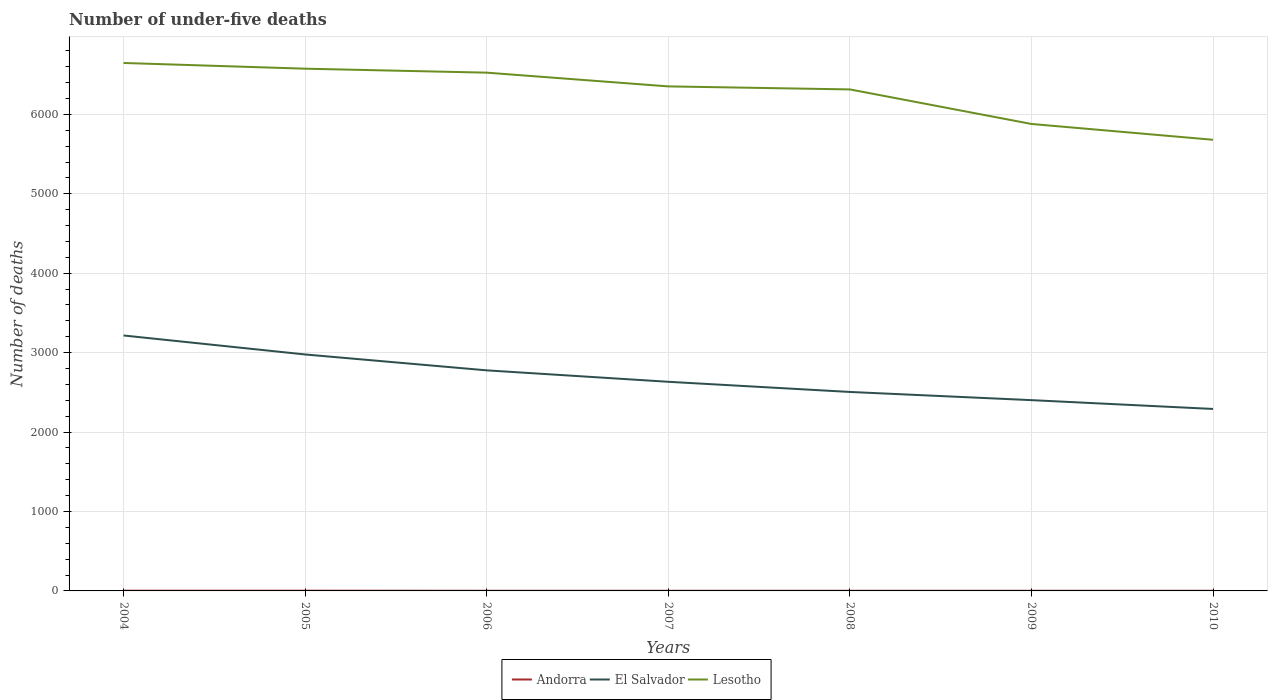How many different coloured lines are there?
Offer a very short reply. 3. Is the number of lines equal to the number of legend labels?
Keep it short and to the point. Yes. Across all years, what is the maximum number of under-five deaths in Lesotho?
Provide a short and direct response. 5680. In which year was the number of under-five deaths in El Salvador maximum?
Offer a very short reply. 2010. What is the difference between the highest and the second highest number of under-five deaths in Lesotho?
Ensure brevity in your answer.  967. Where does the legend appear in the graph?
Your answer should be compact. Bottom center. How many legend labels are there?
Keep it short and to the point. 3. How are the legend labels stacked?
Your answer should be compact. Horizontal. What is the title of the graph?
Offer a terse response. Number of under-five deaths. What is the label or title of the X-axis?
Provide a short and direct response. Years. What is the label or title of the Y-axis?
Offer a very short reply. Number of deaths. What is the Number of deaths in El Salvador in 2004?
Keep it short and to the point. 3216. What is the Number of deaths in Lesotho in 2004?
Ensure brevity in your answer.  6647. What is the Number of deaths in El Salvador in 2005?
Offer a terse response. 2977. What is the Number of deaths of Lesotho in 2005?
Your answer should be very brief. 6575. What is the Number of deaths in El Salvador in 2006?
Keep it short and to the point. 2777. What is the Number of deaths of Lesotho in 2006?
Provide a succinct answer. 6525. What is the Number of deaths in Andorra in 2007?
Your answer should be compact. 2. What is the Number of deaths in El Salvador in 2007?
Keep it short and to the point. 2633. What is the Number of deaths in Lesotho in 2007?
Give a very brief answer. 6352. What is the Number of deaths of Andorra in 2008?
Make the answer very short. 2. What is the Number of deaths of El Salvador in 2008?
Make the answer very short. 2505. What is the Number of deaths of Lesotho in 2008?
Provide a succinct answer. 6314. What is the Number of deaths in El Salvador in 2009?
Your answer should be compact. 2402. What is the Number of deaths of Lesotho in 2009?
Keep it short and to the point. 5879. What is the Number of deaths of Andorra in 2010?
Your answer should be very brief. 2. What is the Number of deaths of El Salvador in 2010?
Provide a short and direct response. 2291. What is the Number of deaths of Lesotho in 2010?
Your answer should be very brief. 5680. Across all years, what is the maximum Number of deaths in El Salvador?
Offer a terse response. 3216. Across all years, what is the maximum Number of deaths of Lesotho?
Ensure brevity in your answer.  6647. Across all years, what is the minimum Number of deaths of El Salvador?
Make the answer very short. 2291. Across all years, what is the minimum Number of deaths in Lesotho?
Offer a terse response. 5680. What is the total Number of deaths of Andorra in the graph?
Keep it short and to the point. 16. What is the total Number of deaths of El Salvador in the graph?
Your response must be concise. 1.88e+04. What is the total Number of deaths of Lesotho in the graph?
Ensure brevity in your answer.  4.40e+04. What is the difference between the Number of deaths in Andorra in 2004 and that in 2005?
Keep it short and to the point. 0. What is the difference between the Number of deaths in El Salvador in 2004 and that in 2005?
Your response must be concise. 239. What is the difference between the Number of deaths in Andorra in 2004 and that in 2006?
Make the answer very short. 1. What is the difference between the Number of deaths of El Salvador in 2004 and that in 2006?
Provide a succinct answer. 439. What is the difference between the Number of deaths in Lesotho in 2004 and that in 2006?
Make the answer very short. 122. What is the difference between the Number of deaths of Andorra in 2004 and that in 2007?
Give a very brief answer. 1. What is the difference between the Number of deaths of El Salvador in 2004 and that in 2007?
Provide a succinct answer. 583. What is the difference between the Number of deaths of Lesotho in 2004 and that in 2007?
Provide a succinct answer. 295. What is the difference between the Number of deaths in El Salvador in 2004 and that in 2008?
Ensure brevity in your answer.  711. What is the difference between the Number of deaths of Lesotho in 2004 and that in 2008?
Provide a succinct answer. 333. What is the difference between the Number of deaths of Andorra in 2004 and that in 2009?
Keep it short and to the point. 1. What is the difference between the Number of deaths of El Salvador in 2004 and that in 2009?
Provide a short and direct response. 814. What is the difference between the Number of deaths of Lesotho in 2004 and that in 2009?
Your answer should be compact. 768. What is the difference between the Number of deaths of Andorra in 2004 and that in 2010?
Ensure brevity in your answer.  1. What is the difference between the Number of deaths in El Salvador in 2004 and that in 2010?
Your answer should be very brief. 925. What is the difference between the Number of deaths in Lesotho in 2004 and that in 2010?
Provide a short and direct response. 967. What is the difference between the Number of deaths in El Salvador in 2005 and that in 2007?
Ensure brevity in your answer.  344. What is the difference between the Number of deaths of Lesotho in 2005 and that in 2007?
Offer a very short reply. 223. What is the difference between the Number of deaths of Andorra in 2005 and that in 2008?
Offer a very short reply. 1. What is the difference between the Number of deaths in El Salvador in 2005 and that in 2008?
Make the answer very short. 472. What is the difference between the Number of deaths in Lesotho in 2005 and that in 2008?
Your answer should be compact. 261. What is the difference between the Number of deaths in El Salvador in 2005 and that in 2009?
Provide a short and direct response. 575. What is the difference between the Number of deaths of Lesotho in 2005 and that in 2009?
Your answer should be compact. 696. What is the difference between the Number of deaths in El Salvador in 2005 and that in 2010?
Your answer should be compact. 686. What is the difference between the Number of deaths of Lesotho in 2005 and that in 2010?
Keep it short and to the point. 895. What is the difference between the Number of deaths of Andorra in 2006 and that in 2007?
Your answer should be compact. 0. What is the difference between the Number of deaths in El Salvador in 2006 and that in 2007?
Your answer should be very brief. 144. What is the difference between the Number of deaths in Lesotho in 2006 and that in 2007?
Offer a very short reply. 173. What is the difference between the Number of deaths in El Salvador in 2006 and that in 2008?
Offer a very short reply. 272. What is the difference between the Number of deaths of Lesotho in 2006 and that in 2008?
Offer a very short reply. 211. What is the difference between the Number of deaths of El Salvador in 2006 and that in 2009?
Offer a terse response. 375. What is the difference between the Number of deaths in Lesotho in 2006 and that in 2009?
Keep it short and to the point. 646. What is the difference between the Number of deaths in Andorra in 2006 and that in 2010?
Provide a succinct answer. 0. What is the difference between the Number of deaths of El Salvador in 2006 and that in 2010?
Give a very brief answer. 486. What is the difference between the Number of deaths in Lesotho in 2006 and that in 2010?
Offer a very short reply. 845. What is the difference between the Number of deaths of Andorra in 2007 and that in 2008?
Give a very brief answer. 0. What is the difference between the Number of deaths of El Salvador in 2007 and that in 2008?
Give a very brief answer. 128. What is the difference between the Number of deaths in Lesotho in 2007 and that in 2008?
Ensure brevity in your answer.  38. What is the difference between the Number of deaths in El Salvador in 2007 and that in 2009?
Offer a very short reply. 231. What is the difference between the Number of deaths of Lesotho in 2007 and that in 2009?
Your answer should be compact. 473. What is the difference between the Number of deaths of Andorra in 2007 and that in 2010?
Provide a succinct answer. 0. What is the difference between the Number of deaths of El Salvador in 2007 and that in 2010?
Make the answer very short. 342. What is the difference between the Number of deaths of Lesotho in 2007 and that in 2010?
Provide a succinct answer. 672. What is the difference between the Number of deaths of El Salvador in 2008 and that in 2009?
Provide a short and direct response. 103. What is the difference between the Number of deaths of Lesotho in 2008 and that in 2009?
Give a very brief answer. 435. What is the difference between the Number of deaths in Andorra in 2008 and that in 2010?
Provide a succinct answer. 0. What is the difference between the Number of deaths in El Salvador in 2008 and that in 2010?
Your answer should be very brief. 214. What is the difference between the Number of deaths of Lesotho in 2008 and that in 2010?
Give a very brief answer. 634. What is the difference between the Number of deaths of El Salvador in 2009 and that in 2010?
Your answer should be compact. 111. What is the difference between the Number of deaths of Lesotho in 2009 and that in 2010?
Keep it short and to the point. 199. What is the difference between the Number of deaths in Andorra in 2004 and the Number of deaths in El Salvador in 2005?
Your response must be concise. -2974. What is the difference between the Number of deaths in Andorra in 2004 and the Number of deaths in Lesotho in 2005?
Provide a short and direct response. -6572. What is the difference between the Number of deaths in El Salvador in 2004 and the Number of deaths in Lesotho in 2005?
Keep it short and to the point. -3359. What is the difference between the Number of deaths of Andorra in 2004 and the Number of deaths of El Salvador in 2006?
Provide a succinct answer. -2774. What is the difference between the Number of deaths of Andorra in 2004 and the Number of deaths of Lesotho in 2006?
Offer a terse response. -6522. What is the difference between the Number of deaths in El Salvador in 2004 and the Number of deaths in Lesotho in 2006?
Your answer should be very brief. -3309. What is the difference between the Number of deaths in Andorra in 2004 and the Number of deaths in El Salvador in 2007?
Your answer should be compact. -2630. What is the difference between the Number of deaths of Andorra in 2004 and the Number of deaths of Lesotho in 2007?
Offer a very short reply. -6349. What is the difference between the Number of deaths of El Salvador in 2004 and the Number of deaths of Lesotho in 2007?
Your answer should be compact. -3136. What is the difference between the Number of deaths of Andorra in 2004 and the Number of deaths of El Salvador in 2008?
Provide a short and direct response. -2502. What is the difference between the Number of deaths in Andorra in 2004 and the Number of deaths in Lesotho in 2008?
Offer a terse response. -6311. What is the difference between the Number of deaths in El Salvador in 2004 and the Number of deaths in Lesotho in 2008?
Your response must be concise. -3098. What is the difference between the Number of deaths in Andorra in 2004 and the Number of deaths in El Salvador in 2009?
Give a very brief answer. -2399. What is the difference between the Number of deaths of Andorra in 2004 and the Number of deaths of Lesotho in 2009?
Your response must be concise. -5876. What is the difference between the Number of deaths in El Salvador in 2004 and the Number of deaths in Lesotho in 2009?
Give a very brief answer. -2663. What is the difference between the Number of deaths of Andorra in 2004 and the Number of deaths of El Salvador in 2010?
Your answer should be compact. -2288. What is the difference between the Number of deaths in Andorra in 2004 and the Number of deaths in Lesotho in 2010?
Give a very brief answer. -5677. What is the difference between the Number of deaths of El Salvador in 2004 and the Number of deaths of Lesotho in 2010?
Your response must be concise. -2464. What is the difference between the Number of deaths in Andorra in 2005 and the Number of deaths in El Salvador in 2006?
Ensure brevity in your answer.  -2774. What is the difference between the Number of deaths of Andorra in 2005 and the Number of deaths of Lesotho in 2006?
Keep it short and to the point. -6522. What is the difference between the Number of deaths in El Salvador in 2005 and the Number of deaths in Lesotho in 2006?
Your answer should be very brief. -3548. What is the difference between the Number of deaths of Andorra in 2005 and the Number of deaths of El Salvador in 2007?
Provide a short and direct response. -2630. What is the difference between the Number of deaths in Andorra in 2005 and the Number of deaths in Lesotho in 2007?
Make the answer very short. -6349. What is the difference between the Number of deaths of El Salvador in 2005 and the Number of deaths of Lesotho in 2007?
Offer a terse response. -3375. What is the difference between the Number of deaths of Andorra in 2005 and the Number of deaths of El Salvador in 2008?
Keep it short and to the point. -2502. What is the difference between the Number of deaths of Andorra in 2005 and the Number of deaths of Lesotho in 2008?
Ensure brevity in your answer.  -6311. What is the difference between the Number of deaths of El Salvador in 2005 and the Number of deaths of Lesotho in 2008?
Offer a very short reply. -3337. What is the difference between the Number of deaths in Andorra in 2005 and the Number of deaths in El Salvador in 2009?
Your response must be concise. -2399. What is the difference between the Number of deaths of Andorra in 2005 and the Number of deaths of Lesotho in 2009?
Your answer should be compact. -5876. What is the difference between the Number of deaths in El Salvador in 2005 and the Number of deaths in Lesotho in 2009?
Your answer should be compact. -2902. What is the difference between the Number of deaths in Andorra in 2005 and the Number of deaths in El Salvador in 2010?
Give a very brief answer. -2288. What is the difference between the Number of deaths of Andorra in 2005 and the Number of deaths of Lesotho in 2010?
Ensure brevity in your answer.  -5677. What is the difference between the Number of deaths in El Salvador in 2005 and the Number of deaths in Lesotho in 2010?
Your response must be concise. -2703. What is the difference between the Number of deaths in Andorra in 2006 and the Number of deaths in El Salvador in 2007?
Provide a succinct answer. -2631. What is the difference between the Number of deaths in Andorra in 2006 and the Number of deaths in Lesotho in 2007?
Keep it short and to the point. -6350. What is the difference between the Number of deaths in El Salvador in 2006 and the Number of deaths in Lesotho in 2007?
Provide a short and direct response. -3575. What is the difference between the Number of deaths in Andorra in 2006 and the Number of deaths in El Salvador in 2008?
Make the answer very short. -2503. What is the difference between the Number of deaths in Andorra in 2006 and the Number of deaths in Lesotho in 2008?
Make the answer very short. -6312. What is the difference between the Number of deaths in El Salvador in 2006 and the Number of deaths in Lesotho in 2008?
Provide a short and direct response. -3537. What is the difference between the Number of deaths of Andorra in 2006 and the Number of deaths of El Salvador in 2009?
Your answer should be very brief. -2400. What is the difference between the Number of deaths of Andorra in 2006 and the Number of deaths of Lesotho in 2009?
Offer a very short reply. -5877. What is the difference between the Number of deaths in El Salvador in 2006 and the Number of deaths in Lesotho in 2009?
Keep it short and to the point. -3102. What is the difference between the Number of deaths of Andorra in 2006 and the Number of deaths of El Salvador in 2010?
Give a very brief answer. -2289. What is the difference between the Number of deaths of Andorra in 2006 and the Number of deaths of Lesotho in 2010?
Your answer should be very brief. -5678. What is the difference between the Number of deaths of El Salvador in 2006 and the Number of deaths of Lesotho in 2010?
Offer a very short reply. -2903. What is the difference between the Number of deaths of Andorra in 2007 and the Number of deaths of El Salvador in 2008?
Provide a succinct answer. -2503. What is the difference between the Number of deaths in Andorra in 2007 and the Number of deaths in Lesotho in 2008?
Keep it short and to the point. -6312. What is the difference between the Number of deaths of El Salvador in 2007 and the Number of deaths of Lesotho in 2008?
Ensure brevity in your answer.  -3681. What is the difference between the Number of deaths of Andorra in 2007 and the Number of deaths of El Salvador in 2009?
Offer a terse response. -2400. What is the difference between the Number of deaths of Andorra in 2007 and the Number of deaths of Lesotho in 2009?
Ensure brevity in your answer.  -5877. What is the difference between the Number of deaths of El Salvador in 2007 and the Number of deaths of Lesotho in 2009?
Provide a succinct answer. -3246. What is the difference between the Number of deaths of Andorra in 2007 and the Number of deaths of El Salvador in 2010?
Your answer should be compact. -2289. What is the difference between the Number of deaths of Andorra in 2007 and the Number of deaths of Lesotho in 2010?
Give a very brief answer. -5678. What is the difference between the Number of deaths of El Salvador in 2007 and the Number of deaths of Lesotho in 2010?
Offer a terse response. -3047. What is the difference between the Number of deaths of Andorra in 2008 and the Number of deaths of El Salvador in 2009?
Offer a terse response. -2400. What is the difference between the Number of deaths of Andorra in 2008 and the Number of deaths of Lesotho in 2009?
Your answer should be very brief. -5877. What is the difference between the Number of deaths in El Salvador in 2008 and the Number of deaths in Lesotho in 2009?
Keep it short and to the point. -3374. What is the difference between the Number of deaths of Andorra in 2008 and the Number of deaths of El Salvador in 2010?
Ensure brevity in your answer.  -2289. What is the difference between the Number of deaths of Andorra in 2008 and the Number of deaths of Lesotho in 2010?
Keep it short and to the point. -5678. What is the difference between the Number of deaths in El Salvador in 2008 and the Number of deaths in Lesotho in 2010?
Offer a terse response. -3175. What is the difference between the Number of deaths of Andorra in 2009 and the Number of deaths of El Salvador in 2010?
Provide a succinct answer. -2289. What is the difference between the Number of deaths of Andorra in 2009 and the Number of deaths of Lesotho in 2010?
Your answer should be very brief. -5678. What is the difference between the Number of deaths of El Salvador in 2009 and the Number of deaths of Lesotho in 2010?
Your answer should be very brief. -3278. What is the average Number of deaths in Andorra per year?
Ensure brevity in your answer.  2.29. What is the average Number of deaths of El Salvador per year?
Your response must be concise. 2685.86. What is the average Number of deaths of Lesotho per year?
Provide a short and direct response. 6281.71. In the year 2004, what is the difference between the Number of deaths of Andorra and Number of deaths of El Salvador?
Offer a very short reply. -3213. In the year 2004, what is the difference between the Number of deaths in Andorra and Number of deaths in Lesotho?
Provide a succinct answer. -6644. In the year 2004, what is the difference between the Number of deaths in El Salvador and Number of deaths in Lesotho?
Your response must be concise. -3431. In the year 2005, what is the difference between the Number of deaths of Andorra and Number of deaths of El Salvador?
Give a very brief answer. -2974. In the year 2005, what is the difference between the Number of deaths in Andorra and Number of deaths in Lesotho?
Ensure brevity in your answer.  -6572. In the year 2005, what is the difference between the Number of deaths in El Salvador and Number of deaths in Lesotho?
Provide a succinct answer. -3598. In the year 2006, what is the difference between the Number of deaths in Andorra and Number of deaths in El Salvador?
Your response must be concise. -2775. In the year 2006, what is the difference between the Number of deaths in Andorra and Number of deaths in Lesotho?
Keep it short and to the point. -6523. In the year 2006, what is the difference between the Number of deaths of El Salvador and Number of deaths of Lesotho?
Make the answer very short. -3748. In the year 2007, what is the difference between the Number of deaths of Andorra and Number of deaths of El Salvador?
Give a very brief answer. -2631. In the year 2007, what is the difference between the Number of deaths of Andorra and Number of deaths of Lesotho?
Make the answer very short. -6350. In the year 2007, what is the difference between the Number of deaths of El Salvador and Number of deaths of Lesotho?
Offer a terse response. -3719. In the year 2008, what is the difference between the Number of deaths in Andorra and Number of deaths in El Salvador?
Keep it short and to the point. -2503. In the year 2008, what is the difference between the Number of deaths in Andorra and Number of deaths in Lesotho?
Your answer should be compact. -6312. In the year 2008, what is the difference between the Number of deaths of El Salvador and Number of deaths of Lesotho?
Your answer should be very brief. -3809. In the year 2009, what is the difference between the Number of deaths in Andorra and Number of deaths in El Salvador?
Ensure brevity in your answer.  -2400. In the year 2009, what is the difference between the Number of deaths in Andorra and Number of deaths in Lesotho?
Make the answer very short. -5877. In the year 2009, what is the difference between the Number of deaths of El Salvador and Number of deaths of Lesotho?
Your answer should be compact. -3477. In the year 2010, what is the difference between the Number of deaths in Andorra and Number of deaths in El Salvador?
Provide a succinct answer. -2289. In the year 2010, what is the difference between the Number of deaths of Andorra and Number of deaths of Lesotho?
Your answer should be very brief. -5678. In the year 2010, what is the difference between the Number of deaths in El Salvador and Number of deaths in Lesotho?
Your response must be concise. -3389. What is the ratio of the Number of deaths in El Salvador in 2004 to that in 2005?
Your answer should be very brief. 1.08. What is the ratio of the Number of deaths in El Salvador in 2004 to that in 2006?
Ensure brevity in your answer.  1.16. What is the ratio of the Number of deaths of Lesotho in 2004 to that in 2006?
Provide a succinct answer. 1.02. What is the ratio of the Number of deaths in Andorra in 2004 to that in 2007?
Provide a succinct answer. 1.5. What is the ratio of the Number of deaths in El Salvador in 2004 to that in 2007?
Provide a short and direct response. 1.22. What is the ratio of the Number of deaths in Lesotho in 2004 to that in 2007?
Keep it short and to the point. 1.05. What is the ratio of the Number of deaths of Andorra in 2004 to that in 2008?
Your answer should be very brief. 1.5. What is the ratio of the Number of deaths of El Salvador in 2004 to that in 2008?
Your answer should be compact. 1.28. What is the ratio of the Number of deaths in Lesotho in 2004 to that in 2008?
Offer a very short reply. 1.05. What is the ratio of the Number of deaths in El Salvador in 2004 to that in 2009?
Keep it short and to the point. 1.34. What is the ratio of the Number of deaths in Lesotho in 2004 to that in 2009?
Provide a succinct answer. 1.13. What is the ratio of the Number of deaths of El Salvador in 2004 to that in 2010?
Your answer should be very brief. 1.4. What is the ratio of the Number of deaths in Lesotho in 2004 to that in 2010?
Offer a terse response. 1.17. What is the ratio of the Number of deaths of El Salvador in 2005 to that in 2006?
Give a very brief answer. 1.07. What is the ratio of the Number of deaths of Lesotho in 2005 to that in 2006?
Give a very brief answer. 1.01. What is the ratio of the Number of deaths in Andorra in 2005 to that in 2007?
Your answer should be very brief. 1.5. What is the ratio of the Number of deaths in El Salvador in 2005 to that in 2007?
Your answer should be compact. 1.13. What is the ratio of the Number of deaths of Lesotho in 2005 to that in 2007?
Offer a very short reply. 1.04. What is the ratio of the Number of deaths in Andorra in 2005 to that in 2008?
Ensure brevity in your answer.  1.5. What is the ratio of the Number of deaths in El Salvador in 2005 to that in 2008?
Make the answer very short. 1.19. What is the ratio of the Number of deaths in Lesotho in 2005 to that in 2008?
Make the answer very short. 1.04. What is the ratio of the Number of deaths in El Salvador in 2005 to that in 2009?
Your answer should be very brief. 1.24. What is the ratio of the Number of deaths in Lesotho in 2005 to that in 2009?
Offer a terse response. 1.12. What is the ratio of the Number of deaths in El Salvador in 2005 to that in 2010?
Your response must be concise. 1.3. What is the ratio of the Number of deaths of Lesotho in 2005 to that in 2010?
Your response must be concise. 1.16. What is the ratio of the Number of deaths in Andorra in 2006 to that in 2007?
Your answer should be very brief. 1. What is the ratio of the Number of deaths of El Salvador in 2006 to that in 2007?
Provide a succinct answer. 1.05. What is the ratio of the Number of deaths of Lesotho in 2006 to that in 2007?
Provide a succinct answer. 1.03. What is the ratio of the Number of deaths of Andorra in 2006 to that in 2008?
Your answer should be very brief. 1. What is the ratio of the Number of deaths of El Salvador in 2006 to that in 2008?
Make the answer very short. 1.11. What is the ratio of the Number of deaths of Lesotho in 2006 to that in 2008?
Offer a very short reply. 1.03. What is the ratio of the Number of deaths in Andorra in 2006 to that in 2009?
Give a very brief answer. 1. What is the ratio of the Number of deaths of El Salvador in 2006 to that in 2009?
Ensure brevity in your answer.  1.16. What is the ratio of the Number of deaths of Lesotho in 2006 to that in 2009?
Provide a short and direct response. 1.11. What is the ratio of the Number of deaths of El Salvador in 2006 to that in 2010?
Your response must be concise. 1.21. What is the ratio of the Number of deaths of Lesotho in 2006 to that in 2010?
Your answer should be compact. 1.15. What is the ratio of the Number of deaths in Andorra in 2007 to that in 2008?
Your answer should be very brief. 1. What is the ratio of the Number of deaths in El Salvador in 2007 to that in 2008?
Make the answer very short. 1.05. What is the ratio of the Number of deaths in Andorra in 2007 to that in 2009?
Offer a terse response. 1. What is the ratio of the Number of deaths of El Salvador in 2007 to that in 2009?
Offer a terse response. 1.1. What is the ratio of the Number of deaths in Lesotho in 2007 to that in 2009?
Keep it short and to the point. 1.08. What is the ratio of the Number of deaths of El Salvador in 2007 to that in 2010?
Offer a very short reply. 1.15. What is the ratio of the Number of deaths in Lesotho in 2007 to that in 2010?
Give a very brief answer. 1.12. What is the ratio of the Number of deaths of Andorra in 2008 to that in 2009?
Your answer should be very brief. 1. What is the ratio of the Number of deaths of El Salvador in 2008 to that in 2009?
Your answer should be very brief. 1.04. What is the ratio of the Number of deaths of Lesotho in 2008 to that in 2009?
Your response must be concise. 1.07. What is the ratio of the Number of deaths in El Salvador in 2008 to that in 2010?
Your answer should be compact. 1.09. What is the ratio of the Number of deaths of Lesotho in 2008 to that in 2010?
Provide a short and direct response. 1.11. What is the ratio of the Number of deaths in El Salvador in 2009 to that in 2010?
Your response must be concise. 1.05. What is the ratio of the Number of deaths of Lesotho in 2009 to that in 2010?
Give a very brief answer. 1.03. What is the difference between the highest and the second highest Number of deaths in El Salvador?
Offer a terse response. 239. What is the difference between the highest and the lowest Number of deaths of Andorra?
Ensure brevity in your answer.  1. What is the difference between the highest and the lowest Number of deaths in El Salvador?
Your answer should be compact. 925. What is the difference between the highest and the lowest Number of deaths in Lesotho?
Your answer should be compact. 967. 